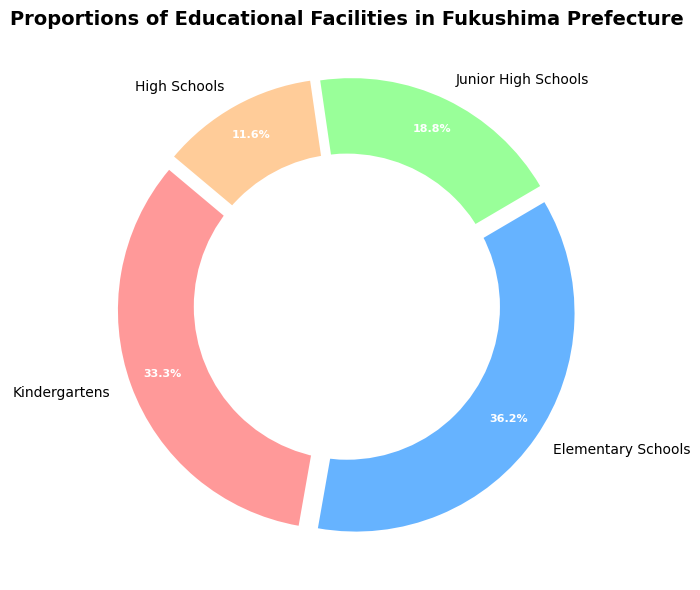Which educational facility type has the highest proportion? The facility with the highest proportion can be identified by looking at the largest slice of the pie chart. Here, the largest slice corresponds to Elementary Schools.
Answer: Elementary Schools What is the combined proportion of Kindergartens and High Schools? To find the combined proportion, look at the individual percentage values for Kindergartens and High Schools, then add them together. Kindergartens are 32.3% and High Schools are 11.2%. So, 32.3% + 11.2% = 43.5%.
Answer: 43.5% How much larger is the proportion of Junior High Schools compared to High Schools? Find the difference between the proportions of Junior High Schools and High Schools. Junior High Schools have 18.2%, and High Schools have 11.2%. The difference is 18.2% - 11.2% = 7%.
Answer: 7% Which facility type is represented by the green color in the chart? Identify the green slice in the pie chart and see which label it corresponds to. Here, the green color corresponds to Junior High Schools.
Answer: Junior High Schools What is the ratio of Elementary Schools to Kindergartens? To determine the ratio, divide the percentage of Elementary Schools by the percentage of Kindergartens. Elementary Schools have 35.2% and Kindergartens have 32.3%. The ratio is 35.2% / 32.3% ≈ 1.09.
Answer: 1.09 Are there more Elementary Schools or Kindergartens in Fukushima? Compare the proportions of Elementary Schools and Kindergartens. Elementary Schools have 35.2%, which is greater than the 32.3% of Kindergartens.
Answer: Elementary Schools What is the smallest category shown on the pie chart? Identify the largest and smallest slices within the pie chart. The smallest slice corresponds to High Schools at 11.2%.
Answer: High Schools If the proportions remained the same, how many High Schools would there be if there were 300 total facilities? Calculate the proportion of High Schools (11.2%) of 300 total facilities. 11.2% of 300 is 0.112 * 300 = 33.6. Since the number of schools should be a whole number, this can be rounded to 34.
Answer: 34 